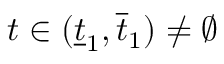Convert formula to latex. <formula><loc_0><loc_0><loc_500><loc_500>t \in ( \underline { t } _ { 1 } , \overline { t } _ { 1 } ) \not = \emptyset</formula> 